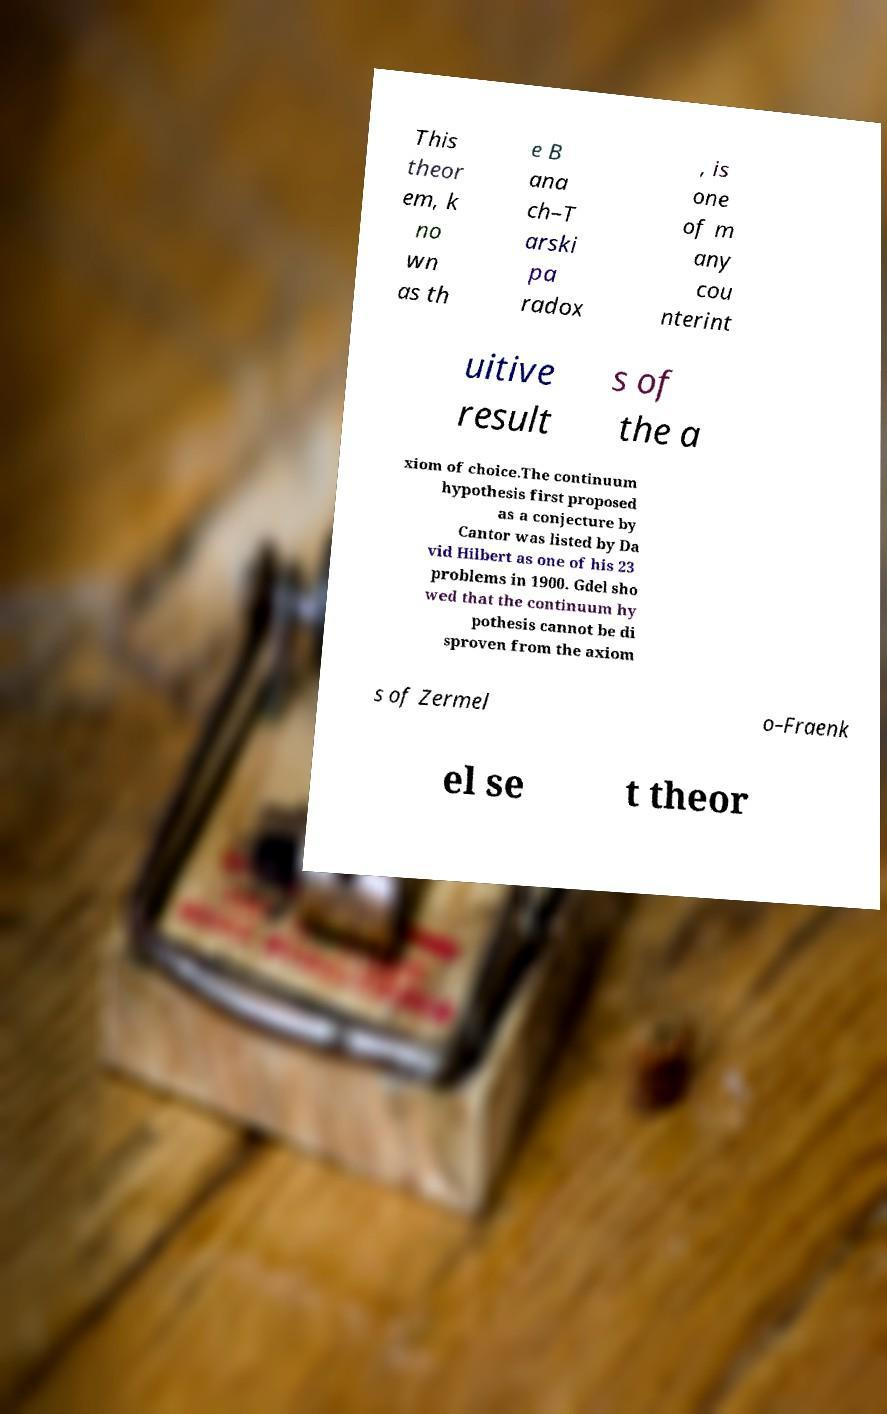Please read and relay the text visible in this image. What does it say? This theor em, k no wn as th e B ana ch–T arski pa radox , is one of m any cou nterint uitive result s of the a xiom of choice.The continuum hypothesis first proposed as a conjecture by Cantor was listed by Da vid Hilbert as one of his 23 problems in 1900. Gdel sho wed that the continuum hy pothesis cannot be di sproven from the axiom s of Zermel o–Fraenk el se t theor 